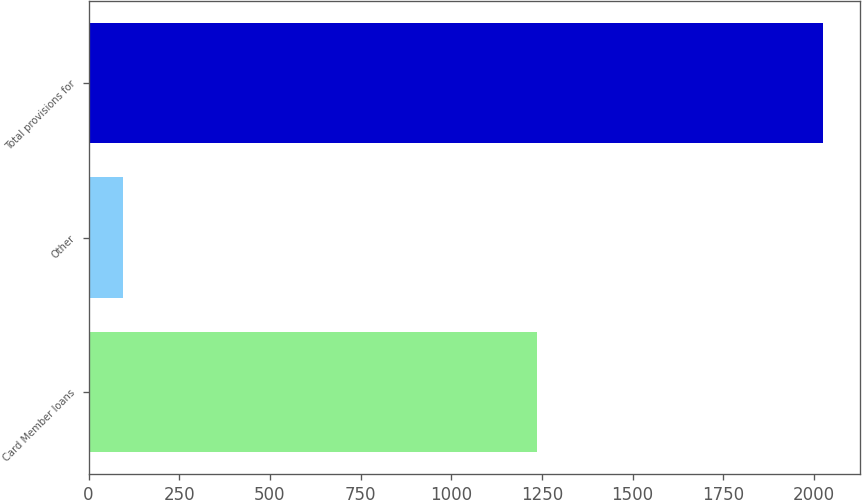Convert chart to OTSL. <chart><loc_0><loc_0><loc_500><loc_500><bar_chart><fcel>Card Member loans<fcel>Other<fcel>Total provisions for<nl><fcel>1235<fcel>95<fcel>2026<nl></chart> 